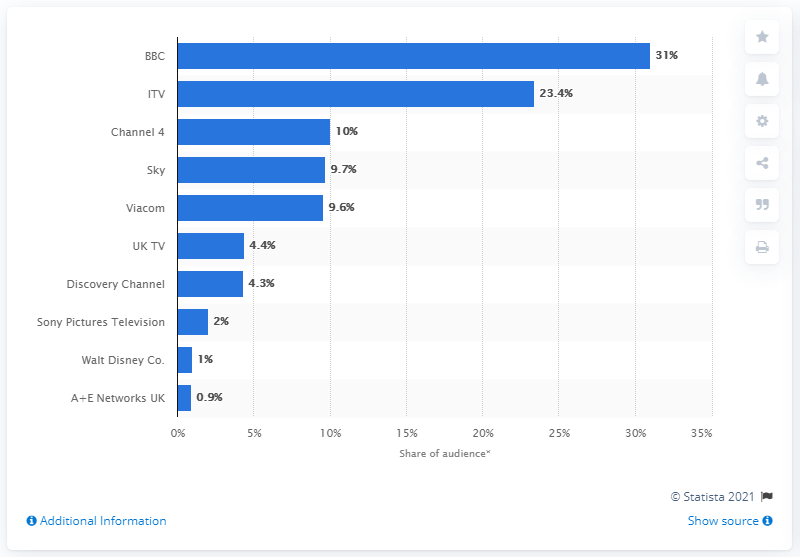Outline some significant characteristics in this image. In 2019, the audience share of the BBC was 31%. The audience shares of ITV and Channel 4 were 31.. in the year.. 